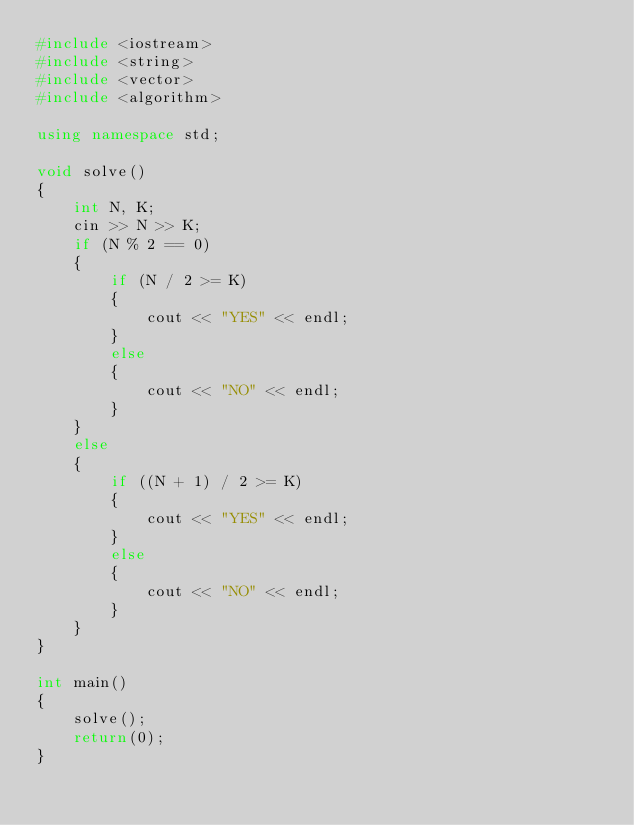<code> <loc_0><loc_0><loc_500><loc_500><_C++_>#include <iostream>
#include <string>
#include <vector>
#include <algorithm>

using namespace std;

void solve()
{
	int N, K;
	cin >> N >> K;
	if (N % 2 == 0)
	{
		if (N / 2 >= K)
		{
			cout << "YES" << endl;
		}
		else
		{
			cout << "NO" << endl;
		}
	}
	else
	{
		if ((N + 1) / 2 >= K)
		{
			cout << "YES" << endl;
		}
		else
		{
			cout << "NO" << endl;
		}
	}
}

int main()
{
	solve();
	return(0);
}</code> 